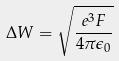Convert formula to latex. <formula><loc_0><loc_0><loc_500><loc_500>\Delta W = \sqrt { \frac { e ^ { 3 } F } { 4 \pi \epsilon _ { 0 } } }</formula> 